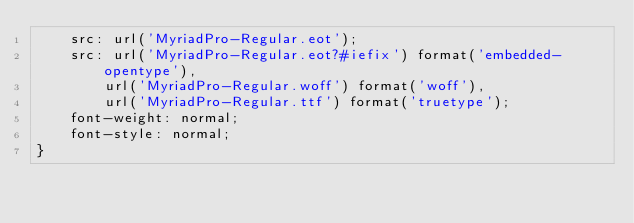<code> <loc_0><loc_0><loc_500><loc_500><_CSS_>	src: url('MyriadPro-Regular.eot');
	src: url('MyriadPro-Regular.eot?#iefix') format('embedded-opentype'),
		url('MyriadPro-Regular.woff') format('woff'),
		url('MyriadPro-Regular.ttf') format('truetype');
	font-weight: normal;
	font-style: normal;
}
</code> 